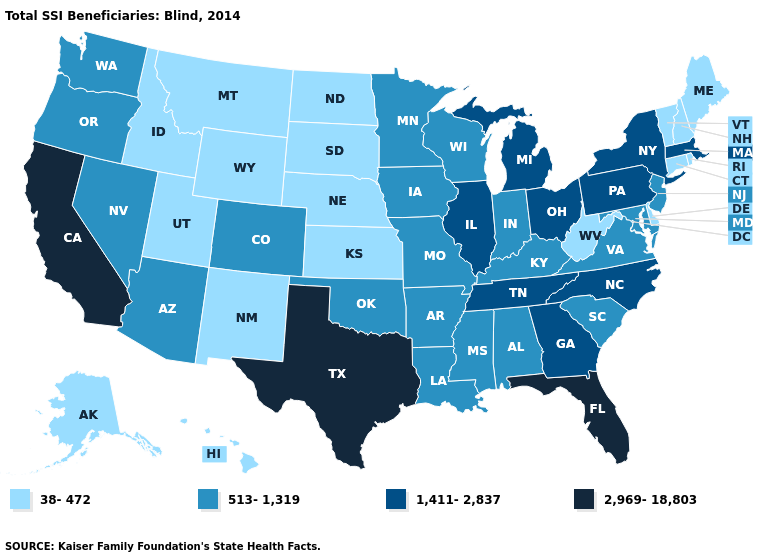What is the value of Nevada?
Concise answer only. 513-1,319. What is the value of Kansas?
Write a very short answer. 38-472. Does South Dakota have the lowest value in the USA?
Short answer required. Yes. Does Ohio have the lowest value in the MidWest?
Be succinct. No. Does Wyoming have the lowest value in the West?
Answer briefly. Yes. Name the states that have a value in the range 1,411-2,837?
Write a very short answer. Georgia, Illinois, Massachusetts, Michigan, New York, North Carolina, Ohio, Pennsylvania, Tennessee. Does Minnesota have the lowest value in the USA?
Write a very short answer. No. What is the lowest value in the South?
Be succinct. 38-472. Which states have the highest value in the USA?
Short answer required. California, Florida, Texas. What is the highest value in the USA?
Answer briefly. 2,969-18,803. Does Idaho have a higher value than Arizona?
Be succinct. No. Which states hav the highest value in the South?
Short answer required. Florida, Texas. Does Rhode Island have the highest value in the USA?
Write a very short answer. No. Is the legend a continuous bar?
Keep it brief. No. 